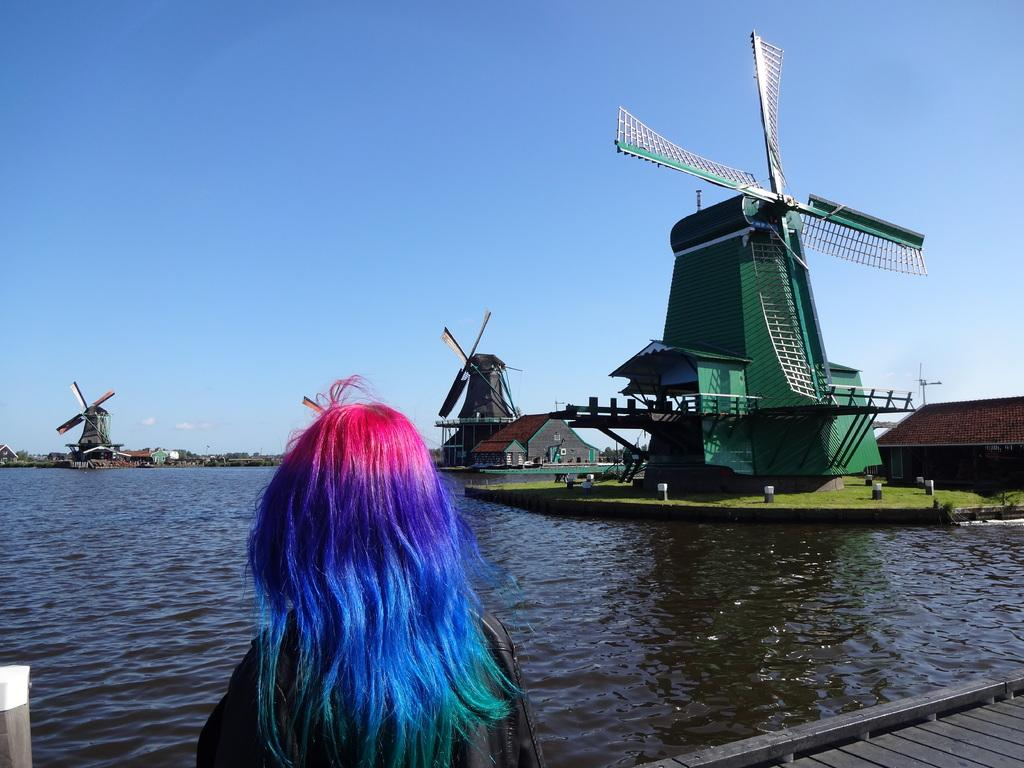Who is the main subject in the image? There is a lady standing in the center of the image. What can be seen in the background of the image? There are windmills and sheds in the background of the image. What is visible at the bottom of the image? There is water visible at the bottom of the image. What part of the natural environment is visible in the image? The sky is visible in the background of the image. What is the purpose of the zebra in the image? There is no zebra present in the image, so it cannot serve any purpose. 